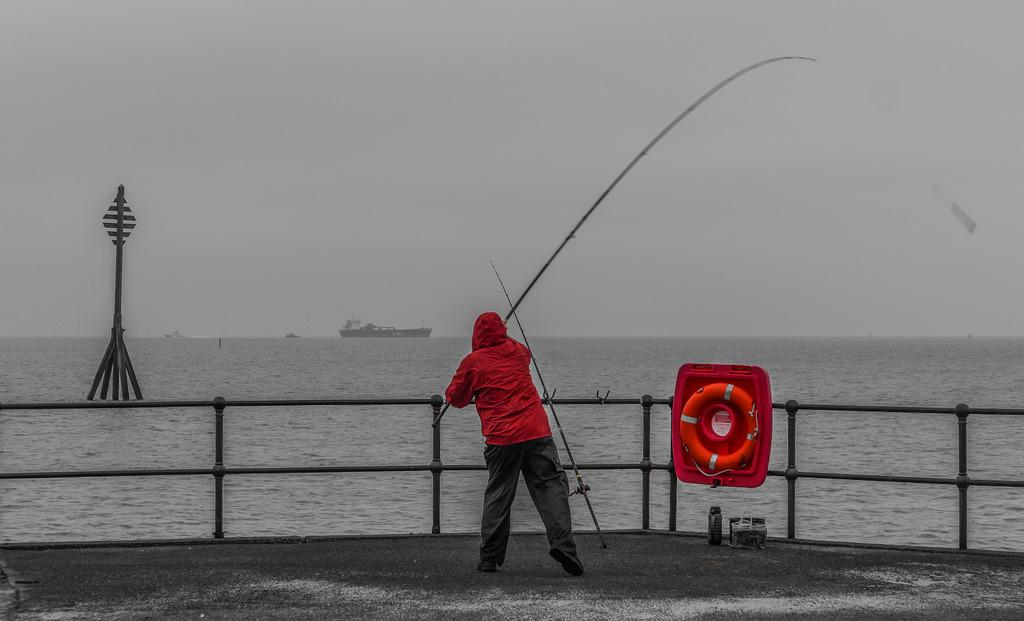What is the man in the image doing? The man is fishing in the image. What is the man wearing while fishing? The man is wearing a red coat. What can be seen in the background of the image? There is a ship traveling in the sea in the background of the image. What is the primary element in which the man is fishing? There is water in the image, and the man is fishing in it. What type of calculator is the man using while fishing? There is no calculator present in the image; the man is fishing with a fishing rod. 